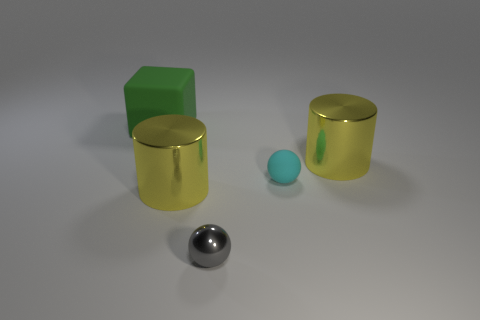Add 1 large blue metal balls. How many objects exist? 6 Subtract all blocks. How many objects are left? 4 Add 2 matte cylinders. How many matte cylinders exist? 2 Subtract 0 brown spheres. How many objects are left? 5 Subtract all large brown things. Subtract all large things. How many objects are left? 2 Add 5 small cyan spheres. How many small cyan spheres are left? 6 